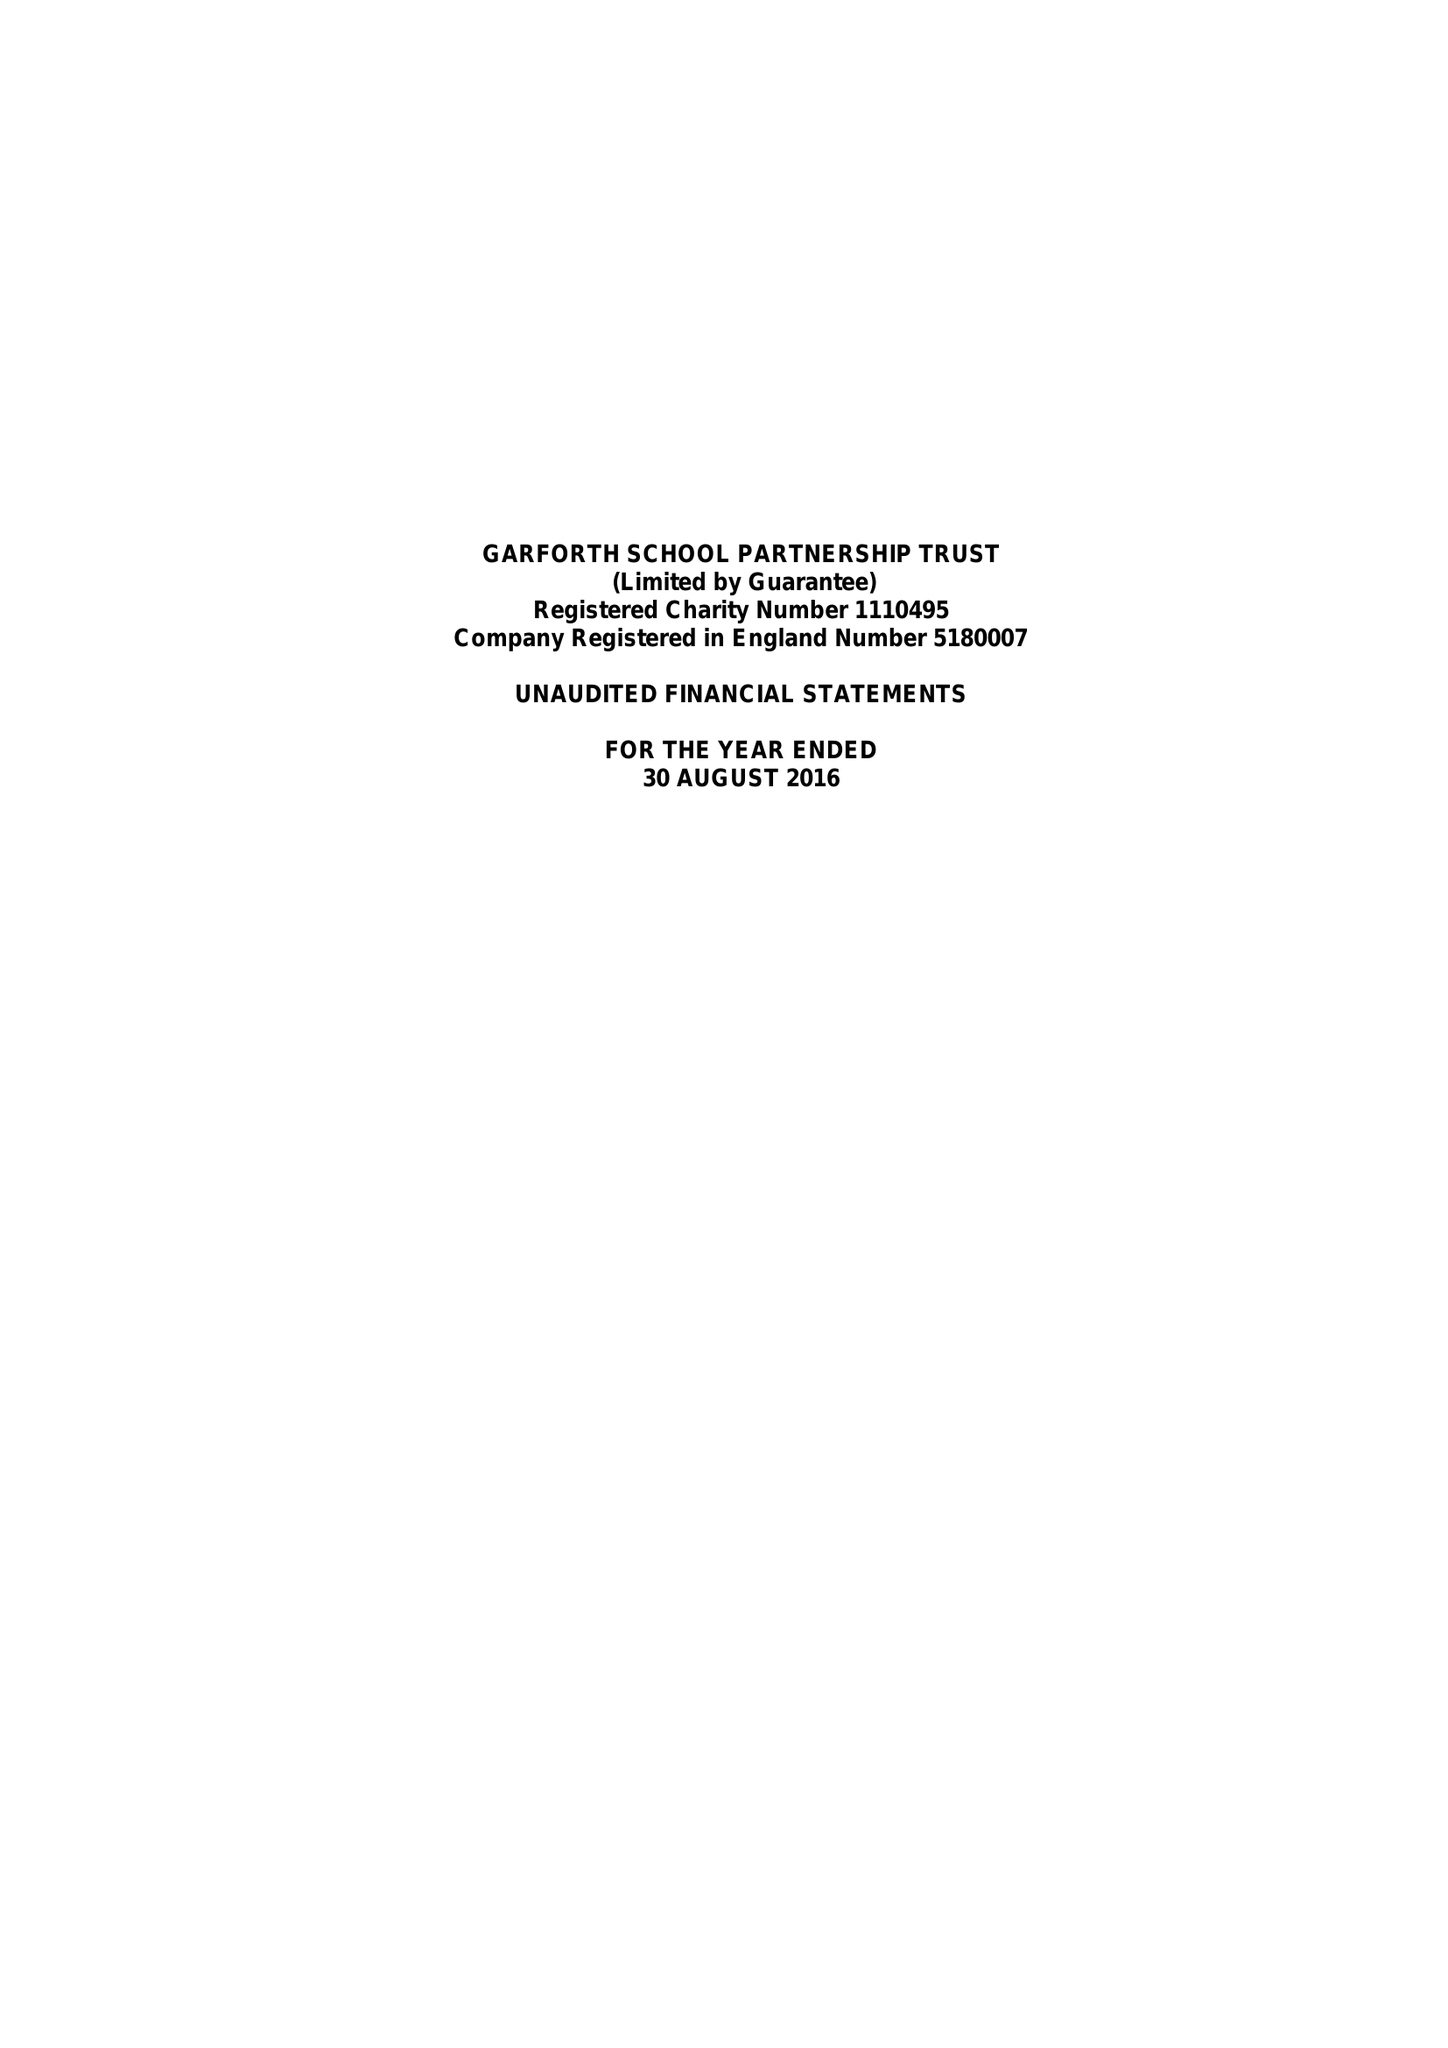What is the value for the charity_name?
Answer the question using a single word or phrase. Garforth School Partnership Trust 